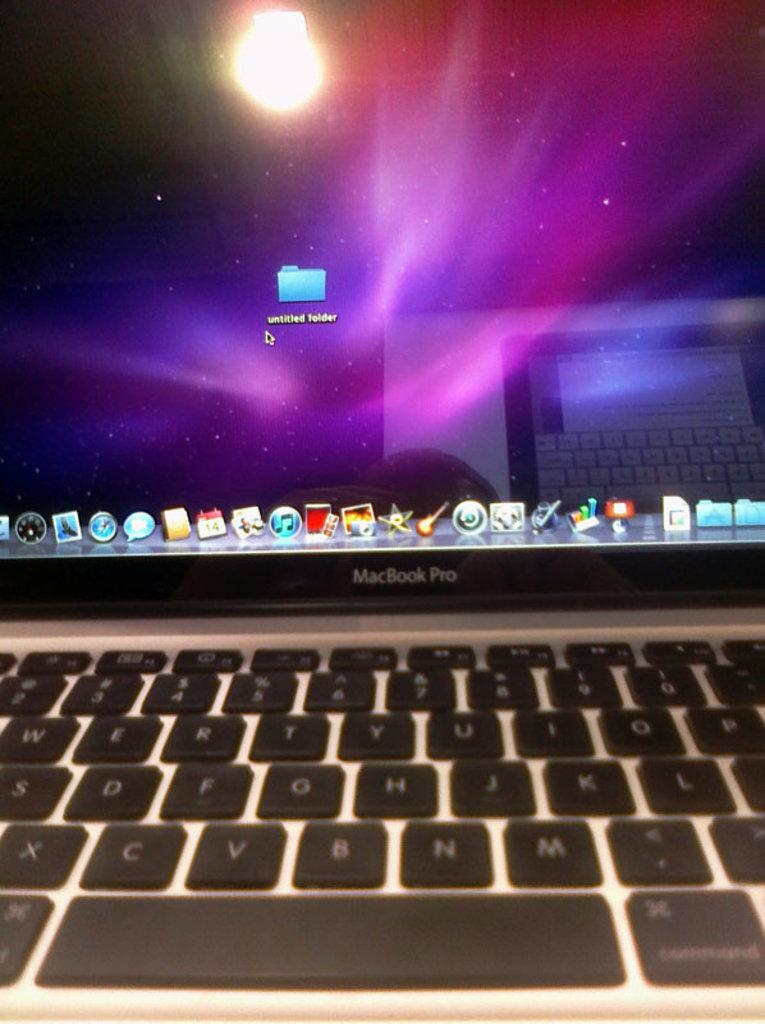<image>
Give a short and clear explanation of the subsequent image. a MacBook Pro with a screen on the Untitled Folder 